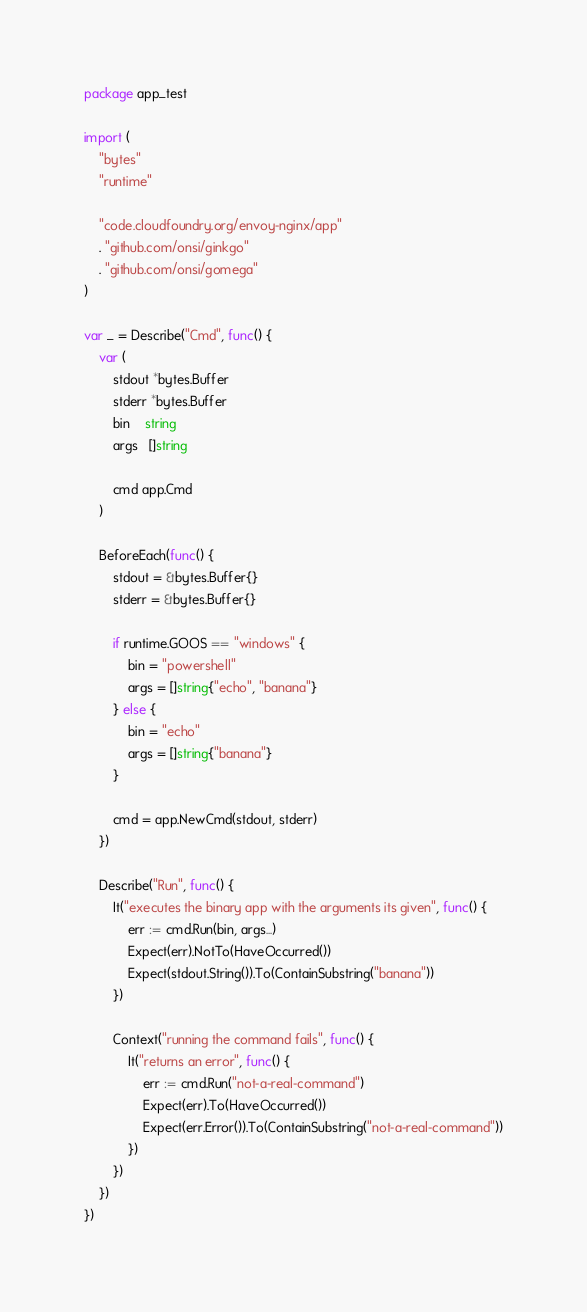<code> <loc_0><loc_0><loc_500><loc_500><_Go_>package app_test

import (
	"bytes"
	"runtime"

	"code.cloudfoundry.org/envoy-nginx/app"
	. "github.com/onsi/ginkgo"
	. "github.com/onsi/gomega"
)

var _ = Describe("Cmd", func() {
	var (
		stdout *bytes.Buffer
		stderr *bytes.Buffer
		bin    string
		args   []string

		cmd app.Cmd
	)

	BeforeEach(func() {
		stdout = &bytes.Buffer{}
		stderr = &bytes.Buffer{}

		if runtime.GOOS == "windows" {
			bin = "powershell"
			args = []string{"echo", "banana"}
		} else {
			bin = "echo"
			args = []string{"banana"}
		}

		cmd = app.NewCmd(stdout, stderr)
	})

	Describe("Run", func() {
		It("executes the binary app with the arguments its given", func() {
			err := cmd.Run(bin, args...)
			Expect(err).NotTo(HaveOccurred())
			Expect(stdout.String()).To(ContainSubstring("banana"))
		})

		Context("running the command fails", func() {
			It("returns an error", func() {
				err := cmd.Run("not-a-real-command")
				Expect(err).To(HaveOccurred())
				Expect(err.Error()).To(ContainSubstring("not-a-real-command"))
			})
		})
	})
})
</code> 